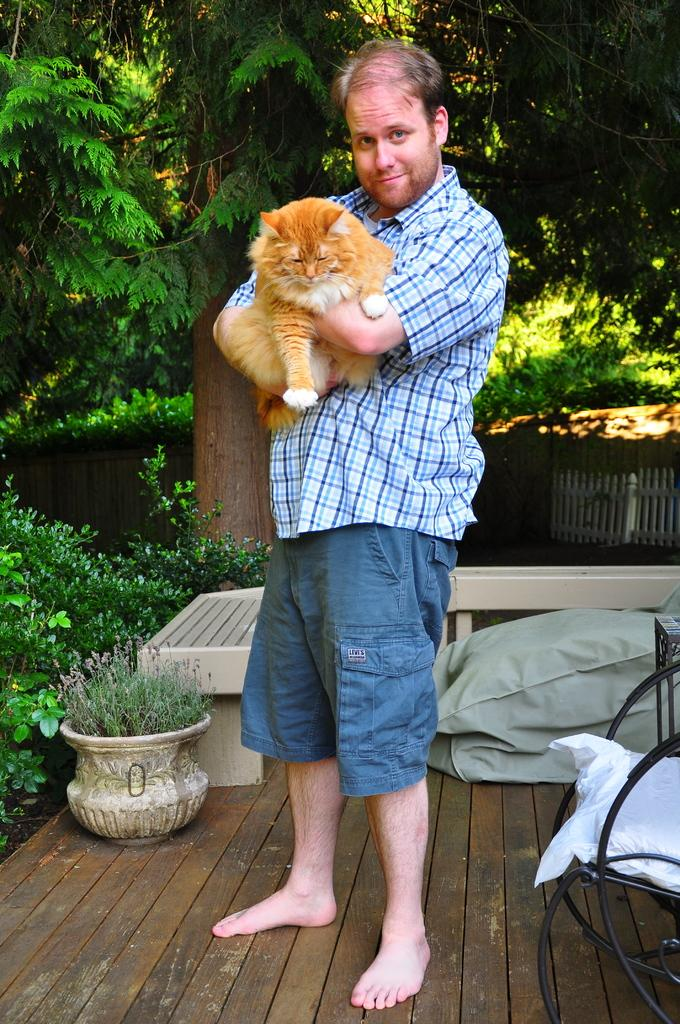What is the main subject of the image? There is a person in the image. What is the person doing in the image? The person is standing and catching a cat in their hand. What can be seen in the background of the image? There are trees visible in the image. Is there any furniture present in the image? Yes, there is a chair in the image. What type of pancake is being prepared on the chair in the image? There is no pancake present in the image, and the chair is not being used for cooking or food preparation. 